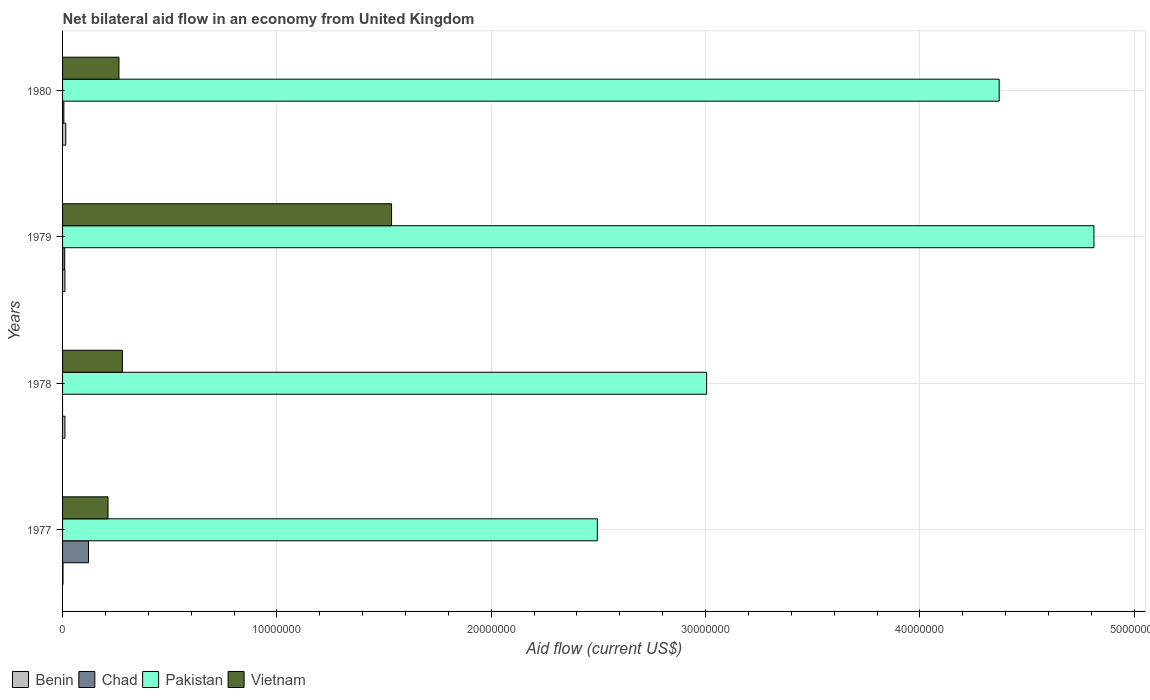How many different coloured bars are there?
Your answer should be very brief. 4. How many groups of bars are there?
Provide a succinct answer. 4. Are the number of bars on each tick of the Y-axis equal?
Your answer should be compact. No. How many bars are there on the 2nd tick from the bottom?
Your answer should be compact. 3. What is the label of the 3rd group of bars from the top?
Your answer should be compact. 1978. What is the net bilateral aid flow in Chad in 1977?
Ensure brevity in your answer.  1.21e+06. Across all years, what is the minimum net bilateral aid flow in Vietnam?
Your response must be concise. 2.12e+06. What is the total net bilateral aid flow in Pakistan in the graph?
Give a very brief answer. 1.47e+08. What is the difference between the net bilateral aid flow in Vietnam in 1977 and that in 1979?
Your response must be concise. -1.32e+07. What is the difference between the net bilateral aid flow in Vietnam in 1980 and the net bilateral aid flow in Chad in 1979?
Provide a short and direct response. 2.53e+06. What is the average net bilateral aid flow in Benin per year?
Provide a succinct answer. 9.75e+04. In the year 1977, what is the difference between the net bilateral aid flow in Vietnam and net bilateral aid flow in Chad?
Provide a short and direct response. 9.10e+05. What is the ratio of the net bilateral aid flow in Pakistan in 1977 to that in 1980?
Make the answer very short. 0.57. What is the difference between the highest and the second highest net bilateral aid flow in Vietnam?
Your response must be concise. 1.26e+07. What is the difference between the highest and the lowest net bilateral aid flow in Benin?
Offer a very short reply. 1.30e+05. In how many years, is the net bilateral aid flow in Vietnam greater than the average net bilateral aid flow in Vietnam taken over all years?
Ensure brevity in your answer.  1. What is the difference between two consecutive major ticks on the X-axis?
Give a very brief answer. 1.00e+07. Does the graph contain any zero values?
Ensure brevity in your answer.  Yes. Does the graph contain grids?
Offer a terse response. Yes. How many legend labels are there?
Offer a terse response. 4. What is the title of the graph?
Your answer should be compact. Net bilateral aid flow in an economy from United Kingdom. What is the Aid flow (current US$) of Benin in 1977?
Your response must be concise. 2.00e+04. What is the Aid flow (current US$) of Chad in 1977?
Make the answer very short. 1.21e+06. What is the Aid flow (current US$) in Pakistan in 1977?
Give a very brief answer. 2.50e+07. What is the Aid flow (current US$) in Vietnam in 1977?
Provide a succinct answer. 2.12e+06. What is the Aid flow (current US$) of Benin in 1978?
Keep it short and to the point. 1.10e+05. What is the Aid flow (current US$) of Chad in 1978?
Offer a terse response. 0. What is the Aid flow (current US$) of Pakistan in 1978?
Your response must be concise. 3.00e+07. What is the Aid flow (current US$) in Vietnam in 1978?
Provide a succinct answer. 2.79e+06. What is the Aid flow (current US$) of Benin in 1979?
Offer a terse response. 1.10e+05. What is the Aid flow (current US$) of Pakistan in 1979?
Your answer should be compact. 4.81e+07. What is the Aid flow (current US$) in Vietnam in 1979?
Your answer should be compact. 1.54e+07. What is the Aid flow (current US$) of Pakistan in 1980?
Give a very brief answer. 4.37e+07. What is the Aid flow (current US$) of Vietnam in 1980?
Keep it short and to the point. 2.63e+06. Across all years, what is the maximum Aid flow (current US$) of Benin?
Your response must be concise. 1.50e+05. Across all years, what is the maximum Aid flow (current US$) in Chad?
Keep it short and to the point. 1.21e+06. Across all years, what is the maximum Aid flow (current US$) of Pakistan?
Offer a terse response. 4.81e+07. Across all years, what is the maximum Aid flow (current US$) of Vietnam?
Offer a terse response. 1.54e+07. Across all years, what is the minimum Aid flow (current US$) of Benin?
Keep it short and to the point. 2.00e+04. Across all years, what is the minimum Aid flow (current US$) in Chad?
Your answer should be very brief. 0. Across all years, what is the minimum Aid flow (current US$) in Pakistan?
Ensure brevity in your answer.  2.50e+07. Across all years, what is the minimum Aid flow (current US$) of Vietnam?
Offer a very short reply. 2.12e+06. What is the total Aid flow (current US$) of Chad in the graph?
Ensure brevity in your answer.  1.37e+06. What is the total Aid flow (current US$) in Pakistan in the graph?
Offer a terse response. 1.47e+08. What is the total Aid flow (current US$) in Vietnam in the graph?
Your answer should be compact. 2.29e+07. What is the difference between the Aid flow (current US$) of Pakistan in 1977 and that in 1978?
Your response must be concise. -5.10e+06. What is the difference between the Aid flow (current US$) in Vietnam in 1977 and that in 1978?
Make the answer very short. -6.70e+05. What is the difference between the Aid flow (current US$) in Chad in 1977 and that in 1979?
Make the answer very short. 1.11e+06. What is the difference between the Aid flow (current US$) in Pakistan in 1977 and that in 1979?
Offer a terse response. -2.32e+07. What is the difference between the Aid flow (current US$) of Vietnam in 1977 and that in 1979?
Your answer should be very brief. -1.32e+07. What is the difference between the Aid flow (current US$) of Benin in 1977 and that in 1980?
Provide a short and direct response. -1.30e+05. What is the difference between the Aid flow (current US$) of Chad in 1977 and that in 1980?
Provide a succinct answer. 1.15e+06. What is the difference between the Aid flow (current US$) in Pakistan in 1977 and that in 1980?
Provide a succinct answer. -1.88e+07. What is the difference between the Aid flow (current US$) of Vietnam in 1977 and that in 1980?
Offer a terse response. -5.10e+05. What is the difference between the Aid flow (current US$) of Pakistan in 1978 and that in 1979?
Your response must be concise. -1.81e+07. What is the difference between the Aid flow (current US$) of Vietnam in 1978 and that in 1979?
Make the answer very short. -1.26e+07. What is the difference between the Aid flow (current US$) of Pakistan in 1978 and that in 1980?
Provide a succinct answer. -1.36e+07. What is the difference between the Aid flow (current US$) in Benin in 1979 and that in 1980?
Ensure brevity in your answer.  -4.00e+04. What is the difference between the Aid flow (current US$) of Pakistan in 1979 and that in 1980?
Your response must be concise. 4.42e+06. What is the difference between the Aid flow (current US$) in Vietnam in 1979 and that in 1980?
Offer a very short reply. 1.27e+07. What is the difference between the Aid flow (current US$) of Benin in 1977 and the Aid flow (current US$) of Pakistan in 1978?
Your answer should be compact. -3.00e+07. What is the difference between the Aid flow (current US$) of Benin in 1977 and the Aid flow (current US$) of Vietnam in 1978?
Your answer should be compact. -2.77e+06. What is the difference between the Aid flow (current US$) in Chad in 1977 and the Aid flow (current US$) in Pakistan in 1978?
Your response must be concise. -2.88e+07. What is the difference between the Aid flow (current US$) of Chad in 1977 and the Aid flow (current US$) of Vietnam in 1978?
Ensure brevity in your answer.  -1.58e+06. What is the difference between the Aid flow (current US$) of Pakistan in 1977 and the Aid flow (current US$) of Vietnam in 1978?
Provide a short and direct response. 2.22e+07. What is the difference between the Aid flow (current US$) of Benin in 1977 and the Aid flow (current US$) of Pakistan in 1979?
Offer a terse response. -4.81e+07. What is the difference between the Aid flow (current US$) in Benin in 1977 and the Aid flow (current US$) in Vietnam in 1979?
Offer a very short reply. -1.53e+07. What is the difference between the Aid flow (current US$) in Chad in 1977 and the Aid flow (current US$) in Pakistan in 1979?
Your answer should be compact. -4.69e+07. What is the difference between the Aid flow (current US$) in Chad in 1977 and the Aid flow (current US$) in Vietnam in 1979?
Ensure brevity in your answer.  -1.41e+07. What is the difference between the Aid flow (current US$) of Pakistan in 1977 and the Aid flow (current US$) of Vietnam in 1979?
Make the answer very short. 9.60e+06. What is the difference between the Aid flow (current US$) of Benin in 1977 and the Aid flow (current US$) of Chad in 1980?
Make the answer very short. -4.00e+04. What is the difference between the Aid flow (current US$) in Benin in 1977 and the Aid flow (current US$) in Pakistan in 1980?
Make the answer very short. -4.37e+07. What is the difference between the Aid flow (current US$) of Benin in 1977 and the Aid flow (current US$) of Vietnam in 1980?
Provide a succinct answer. -2.61e+06. What is the difference between the Aid flow (current US$) of Chad in 1977 and the Aid flow (current US$) of Pakistan in 1980?
Make the answer very short. -4.25e+07. What is the difference between the Aid flow (current US$) in Chad in 1977 and the Aid flow (current US$) in Vietnam in 1980?
Offer a terse response. -1.42e+06. What is the difference between the Aid flow (current US$) of Pakistan in 1977 and the Aid flow (current US$) of Vietnam in 1980?
Your answer should be compact. 2.23e+07. What is the difference between the Aid flow (current US$) of Benin in 1978 and the Aid flow (current US$) of Chad in 1979?
Offer a terse response. 10000. What is the difference between the Aid flow (current US$) of Benin in 1978 and the Aid flow (current US$) of Pakistan in 1979?
Offer a very short reply. -4.80e+07. What is the difference between the Aid flow (current US$) of Benin in 1978 and the Aid flow (current US$) of Vietnam in 1979?
Offer a terse response. -1.52e+07. What is the difference between the Aid flow (current US$) of Pakistan in 1978 and the Aid flow (current US$) of Vietnam in 1979?
Provide a succinct answer. 1.47e+07. What is the difference between the Aid flow (current US$) in Benin in 1978 and the Aid flow (current US$) in Chad in 1980?
Provide a succinct answer. 5.00e+04. What is the difference between the Aid flow (current US$) of Benin in 1978 and the Aid flow (current US$) of Pakistan in 1980?
Your response must be concise. -4.36e+07. What is the difference between the Aid flow (current US$) of Benin in 1978 and the Aid flow (current US$) of Vietnam in 1980?
Give a very brief answer. -2.52e+06. What is the difference between the Aid flow (current US$) in Pakistan in 1978 and the Aid flow (current US$) in Vietnam in 1980?
Make the answer very short. 2.74e+07. What is the difference between the Aid flow (current US$) in Benin in 1979 and the Aid flow (current US$) in Chad in 1980?
Make the answer very short. 5.00e+04. What is the difference between the Aid flow (current US$) in Benin in 1979 and the Aid flow (current US$) in Pakistan in 1980?
Offer a terse response. -4.36e+07. What is the difference between the Aid flow (current US$) in Benin in 1979 and the Aid flow (current US$) in Vietnam in 1980?
Ensure brevity in your answer.  -2.52e+06. What is the difference between the Aid flow (current US$) of Chad in 1979 and the Aid flow (current US$) of Pakistan in 1980?
Make the answer very short. -4.36e+07. What is the difference between the Aid flow (current US$) in Chad in 1979 and the Aid flow (current US$) in Vietnam in 1980?
Offer a terse response. -2.53e+06. What is the difference between the Aid flow (current US$) in Pakistan in 1979 and the Aid flow (current US$) in Vietnam in 1980?
Your response must be concise. 4.55e+07. What is the average Aid flow (current US$) in Benin per year?
Provide a short and direct response. 9.75e+04. What is the average Aid flow (current US$) of Chad per year?
Ensure brevity in your answer.  3.42e+05. What is the average Aid flow (current US$) in Pakistan per year?
Provide a short and direct response. 3.67e+07. What is the average Aid flow (current US$) of Vietnam per year?
Give a very brief answer. 5.72e+06. In the year 1977, what is the difference between the Aid flow (current US$) in Benin and Aid flow (current US$) in Chad?
Ensure brevity in your answer.  -1.19e+06. In the year 1977, what is the difference between the Aid flow (current US$) of Benin and Aid flow (current US$) of Pakistan?
Ensure brevity in your answer.  -2.49e+07. In the year 1977, what is the difference between the Aid flow (current US$) of Benin and Aid flow (current US$) of Vietnam?
Give a very brief answer. -2.10e+06. In the year 1977, what is the difference between the Aid flow (current US$) of Chad and Aid flow (current US$) of Pakistan?
Keep it short and to the point. -2.37e+07. In the year 1977, what is the difference between the Aid flow (current US$) in Chad and Aid flow (current US$) in Vietnam?
Offer a very short reply. -9.10e+05. In the year 1977, what is the difference between the Aid flow (current US$) of Pakistan and Aid flow (current US$) of Vietnam?
Provide a succinct answer. 2.28e+07. In the year 1978, what is the difference between the Aid flow (current US$) in Benin and Aid flow (current US$) in Pakistan?
Ensure brevity in your answer.  -2.99e+07. In the year 1978, what is the difference between the Aid flow (current US$) in Benin and Aid flow (current US$) in Vietnam?
Provide a short and direct response. -2.68e+06. In the year 1978, what is the difference between the Aid flow (current US$) of Pakistan and Aid flow (current US$) of Vietnam?
Offer a terse response. 2.73e+07. In the year 1979, what is the difference between the Aid flow (current US$) of Benin and Aid flow (current US$) of Chad?
Your answer should be compact. 10000. In the year 1979, what is the difference between the Aid flow (current US$) in Benin and Aid flow (current US$) in Pakistan?
Make the answer very short. -4.80e+07. In the year 1979, what is the difference between the Aid flow (current US$) of Benin and Aid flow (current US$) of Vietnam?
Give a very brief answer. -1.52e+07. In the year 1979, what is the difference between the Aid flow (current US$) in Chad and Aid flow (current US$) in Pakistan?
Your response must be concise. -4.80e+07. In the year 1979, what is the difference between the Aid flow (current US$) of Chad and Aid flow (current US$) of Vietnam?
Provide a succinct answer. -1.52e+07. In the year 1979, what is the difference between the Aid flow (current US$) of Pakistan and Aid flow (current US$) of Vietnam?
Provide a short and direct response. 3.28e+07. In the year 1980, what is the difference between the Aid flow (current US$) in Benin and Aid flow (current US$) in Pakistan?
Provide a succinct answer. -4.36e+07. In the year 1980, what is the difference between the Aid flow (current US$) in Benin and Aid flow (current US$) in Vietnam?
Offer a very short reply. -2.48e+06. In the year 1980, what is the difference between the Aid flow (current US$) of Chad and Aid flow (current US$) of Pakistan?
Make the answer very short. -4.36e+07. In the year 1980, what is the difference between the Aid flow (current US$) in Chad and Aid flow (current US$) in Vietnam?
Give a very brief answer. -2.57e+06. In the year 1980, what is the difference between the Aid flow (current US$) in Pakistan and Aid flow (current US$) in Vietnam?
Make the answer very short. 4.11e+07. What is the ratio of the Aid flow (current US$) in Benin in 1977 to that in 1978?
Your answer should be very brief. 0.18. What is the ratio of the Aid flow (current US$) of Pakistan in 1977 to that in 1978?
Offer a very short reply. 0.83. What is the ratio of the Aid flow (current US$) of Vietnam in 1977 to that in 1978?
Ensure brevity in your answer.  0.76. What is the ratio of the Aid flow (current US$) in Benin in 1977 to that in 1979?
Provide a short and direct response. 0.18. What is the ratio of the Aid flow (current US$) of Pakistan in 1977 to that in 1979?
Your answer should be compact. 0.52. What is the ratio of the Aid flow (current US$) in Vietnam in 1977 to that in 1979?
Give a very brief answer. 0.14. What is the ratio of the Aid flow (current US$) of Benin in 1977 to that in 1980?
Offer a very short reply. 0.13. What is the ratio of the Aid flow (current US$) in Chad in 1977 to that in 1980?
Make the answer very short. 20.17. What is the ratio of the Aid flow (current US$) in Pakistan in 1977 to that in 1980?
Provide a short and direct response. 0.57. What is the ratio of the Aid flow (current US$) of Vietnam in 1977 to that in 1980?
Your answer should be compact. 0.81. What is the ratio of the Aid flow (current US$) in Benin in 1978 to that in 1979?
Your answer should be very brief. 1. What is the ratio of the Aid flow (current US$) of Pakistan in 1978 to that in 1979?
Make the answer very short. 0.62. What is the ratio of the Aid flow (current US$) of Vietnam in 1978 to that in 1979?
Offer a very short reply. 0.18. What is the ratio of the Aid flow (current US$) in Benin in 1978 to that in 1980?
Ensure brevity in your answer.  0.73. What is the ratio of the Aid flow (current US$) in Pakistan in 1978 to that in 1980?
Give a very brief answer. 0.69. What is the ratio of the Aid flow (current US$) of Vietnam in 1978 to that in 1980?
Give a very brief answer. 1.06. What is the ratio of the Aid flow (current US$) of Benin in 1979 to that in 1980?
Give a very brief answer. 0.73. What is the ratio of the Aid flow (current US$) in Pakistan in 1979 to that in 1980?
Keep it short and to the point. 1.1. What is the ratio of the Aid flow (current US$) in Vietnam in 1979 to that in 1980?
Ensure brevity in your answer.  5.84. What is the difference between the highest and the second highest Aid flow (current US$) of Benin?
Your answer should be compact. 4.00e+04. What is the difference between the highest and the second highest Aid flow (current US$) in Chad?
Provide a succinct answer. 1.11e+06. What is the difference between the highest and the second highest Aid flow (current US$) in Pakistan?
Ensure brevity in your answer.  4.42e+06. What is the difference between the highest and the second highest Aid flow (current US$) of Vietnam?
Give a very brief answer. 1.26e+07. What is the difference between the highest and the lowest Aid flow (current US$) in Chad?
Provide a succinct answer. 1.21e+06. What is the difference between the highest and the lowest Aid flow (current US$) in Pakistan?
Your answer should be very brief. 2.32e+07. What is the difference between the highest and the lowest Aid flow (current US$) of Vietnam?
Keep it short and to the point. 1.32e+07. 